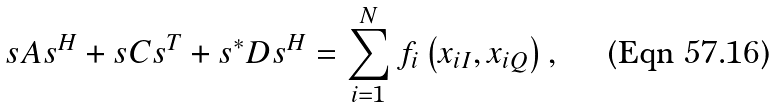<formula> <loc_0><loc_0><loc_500><loc_500>s A s ^ { H } + s C s ^ { T } + s ^ { * } D s ^ { H } = \sum _ { i = 1 } ^ { N } f _ { i } \left ( x _ { i I } , x _ { i Q } \right ) ,</formula> 